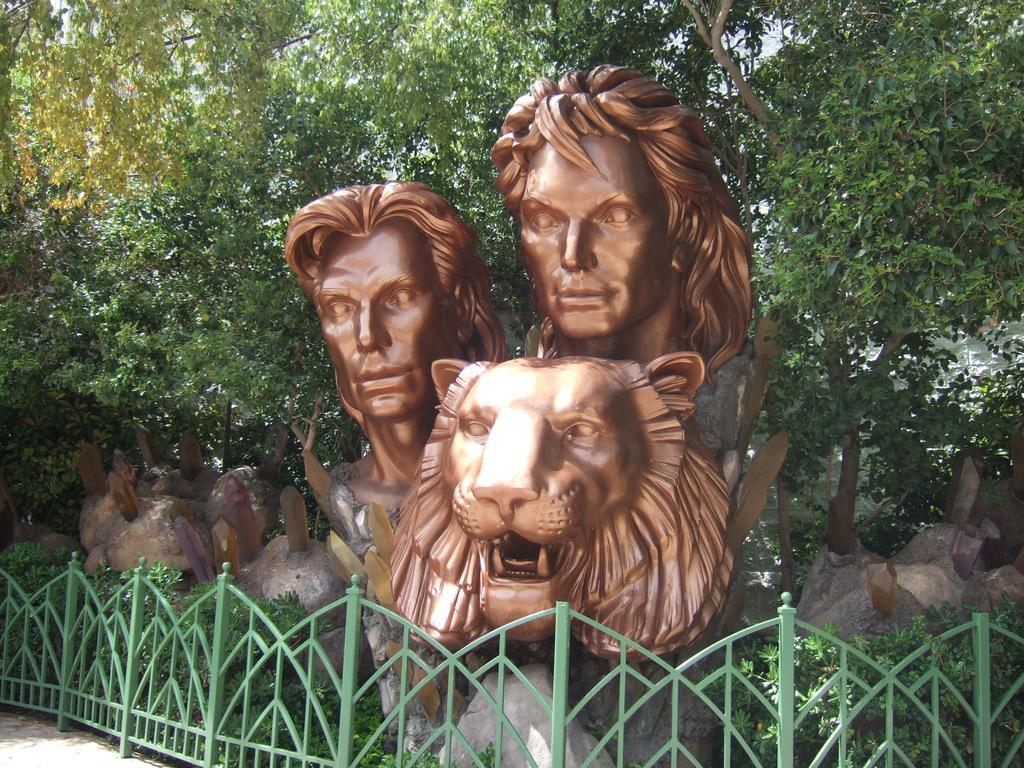What type of objects can be seen in the image? There are statues in the image. What is the purpose of the structure visible in the image? There is a fence in the image, which is likely used to enclose or separate an area. What type of natural elements can be seen in the image? There are rocks and trees in the image. What type of glass is used to make the statues in the image? There is no mention of glass being used to make the statues in the image. The statues are likely made of a different material, such as stone or metal. 